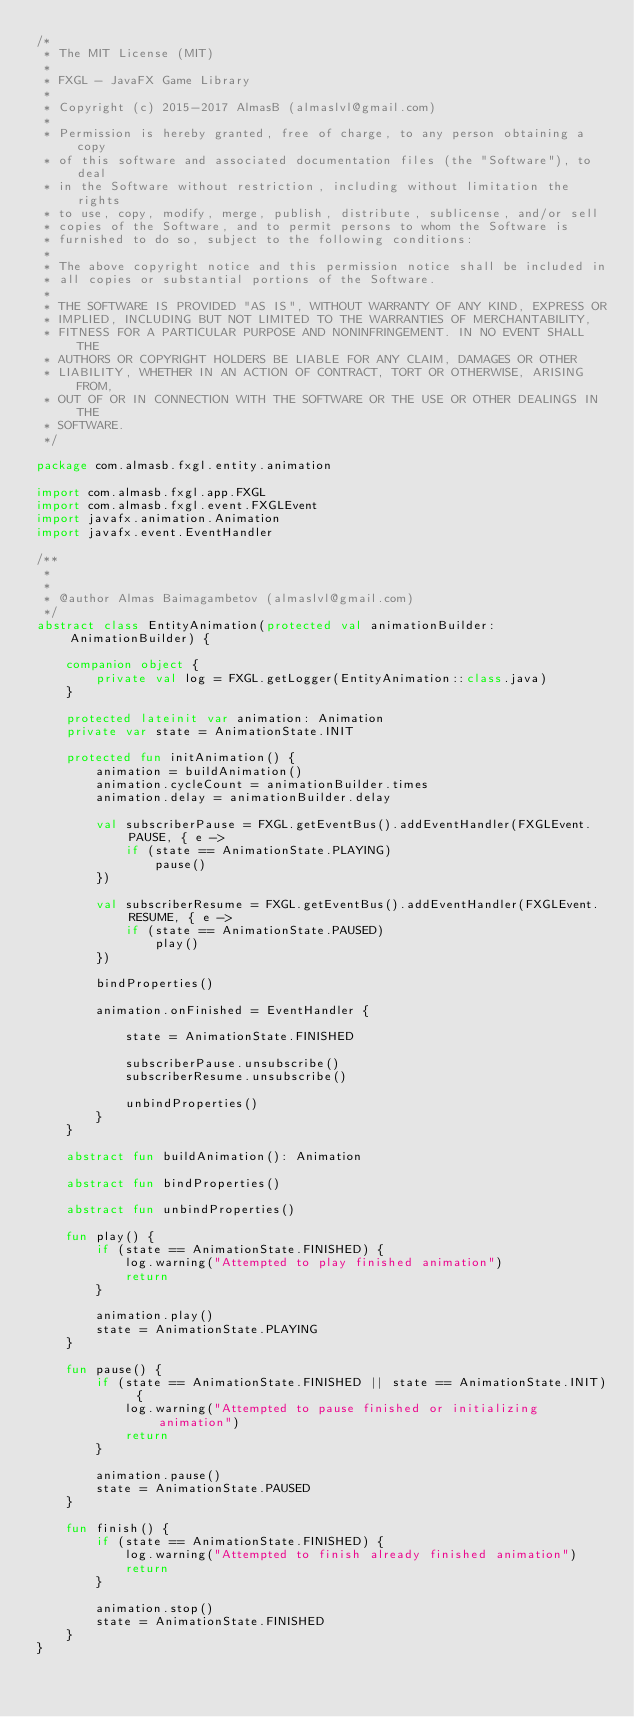Convert code to text. <code><loc_0><loc_0><loc_500><loc_500><_Kotlin_>/*
 * The MIT License (MIT)
 *
 * FXGL - JavaFX Game Library
 *
 * Copyright (c) 2015-2017 AlmasB (almaslvl@gmail.com)
 *
 * Permission is hereby granted, free of charge, to any person obtaining a copy
 * of this software and associated documentation files (the "Software"), to deal
 * in the Software without restriction, including without limitation the rights
 * to use, copy, modify, merge, publish, distribute, sublicense, and/or sell
 * copies of the Software, and to permit persons to whom the Software is
 * furnished to do so, subject to the following conditions:
 *
 * The above copyright notice and this permission notice shall be included in
 * all copies or substantial portions of the Software.
 *
 * THE SOFTWARE IS PROVIDED "AS IS", WITHOUT WARRANTY OF ANY KIND, EXPRESS OR
 * IMPLIED, INCLUDING BUT NOT LIMITED TO THE WARRANTIES OF MERCHANTABILITY,
 * FITNESS FOR A PARTICULAR PURPOSE AND NONINFRINGEMENT. IN NO EVENT SHALL THE
 * AUTHORS OR COPYRIGHT HOLDERS BE LIABLE FOR ANY CLAIM, DAMAGES OR OTHER
 * LIABILITY, WHETHER IN AN ACTION OF CONTRACT, TORT OR OTHERWISE, ARISING FROM,
 * OUT OF OR IN CONNECTION WITH THE SOFTWARE OR THE USE OR OTHER DEALINGS IN THE
 * SOFTWARE.
 */

package com.almasb.fxgl.entity.animation

import com.almasb.fxgl.app.FXGL
import com.almasb.fxgl.event.FXGLEvent
import javafx.animation.Animation
import javafx.event.EventHandler

/**
 *
 *
 * @author Almas Baimagambetov (almaslvl@gmail.com)
 */
abstract class EntityAnimation(protected val animationBuilder: AnimationBuilder) {

    companion object {
        private val log = FXGL.getLogger(EntityAnimation::class.java)
    }

    protected lateinit var animation: Animation
    private var state = AnimationState.INIT

    protected fun initAnimation() {
        animation = buildAnimation()
        animation.cycleCount = animationBuilder.times
        animation.delay = animationBuilder.delay

        val subscriberPause = FXGL.getEventBus().addEventHandler(FXGLEvent.PAUSE, { e ->
            if (state == AnimationState.PLAYING)
                pause()
        })

        val subscriberResume = FXGL.getEventBus().addEventHandler(FXGLEvent.RESUME, { e ->
            if (state == AnimationState.PAUSED)
                play()
        })

        bindProperties()

        animation.onFinished = EventHandler {

            state = AnimationState.FINISHED

            subscriberPause.unsubscribe()
            subscriberResume.unsubscribe()

            unbindProperties()
        }
    }

    abstract fun buildAnimation(): Animation

    abstract fun bindProperties()

    abstract fun unbindProperties()

    fun play() {
        if (state == AnimationState.FINISHED) {
            log.warning("Attempted to play finished animation")
            return
        }

        animation.play()
        state = AnimationState.PLAYING
    }

    fun pause() {
        if (state == AnimationState.FINISHED || state == AnimationState.INIT) {
            log.warning("Attempted to pause finished or initializing animation")
            return
        }

        animation.pause()
        state = AnimationState.PAUSED
    }

    fun finish() {
        if (state == AnimationState.FINISHED) {
            log.warning("Attempted to finish already finished animation")
            return
        }

        animation.stop()
        state = AnimationState.FINISHED
    }
}</code> 